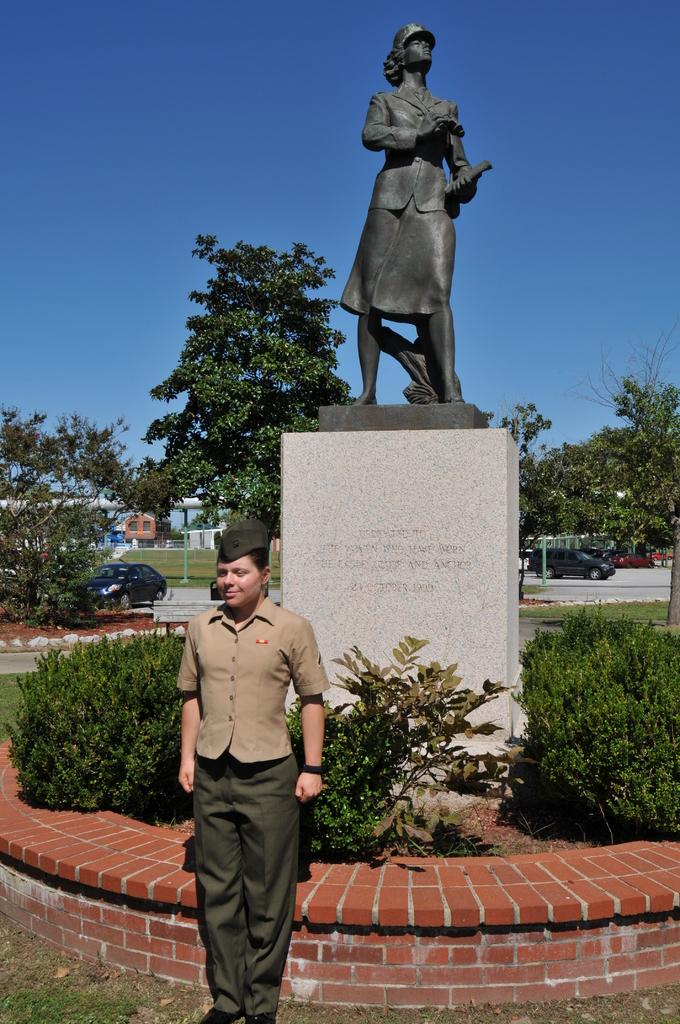What is the main subject in the image? There is a statue in the image. What is the man in the image doing? A man is standing on the ground in front of the statue. What type of vegetation is present in the image? There are trees in the image. What is happening in the background of the image? There are cars traveling on a road in the image. What can be seen above the statue and the man? The sky is visible in the image. What type of feast is being held in front of the statue in the image? There is no feast present in the image; it only shows a statue and a man standing in front of it. Can you see any deer in the image? There are no deer present in the image. 